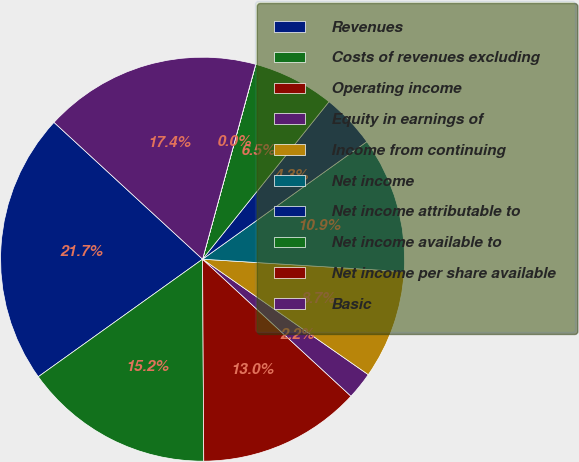Convert chart. <chart><loc_0><loc_0><loc_500><loc_500><pie_chart><fcel>Revenues<fcel>Costs of revenues excluding<fcel>Operating income<fcel>Equity in earnings of<fcel>Income from continuing<fcel>Net income<fcel>Net income attributable to<fcel>Net income available to<fcel>Net income per share available<fcel>Basic<nl><fcel>21.73%<fcel>15.21%<fcel>13.04%<fcel>2.18%<fcel>8.7%<fcel>10.87%<fcel>4.35%<fcel>6.52%<fcel>0.01%<fcel>17.39%<nl></chart> 